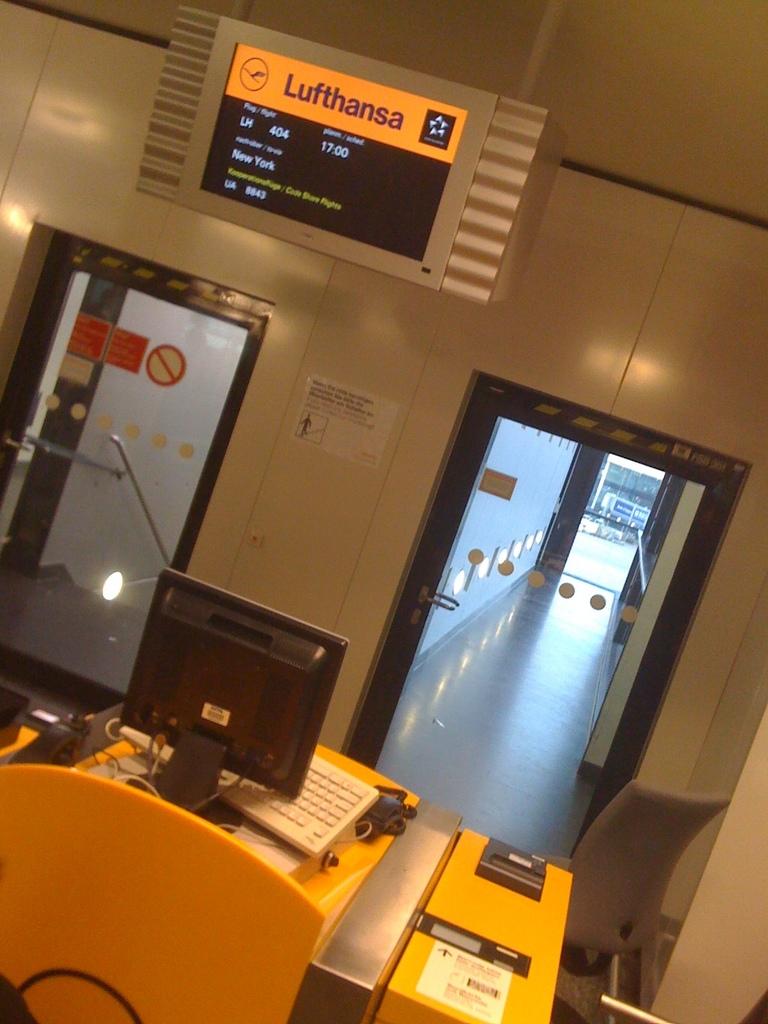What state is listed in the sign?
Provide a short and direct response. New york. 